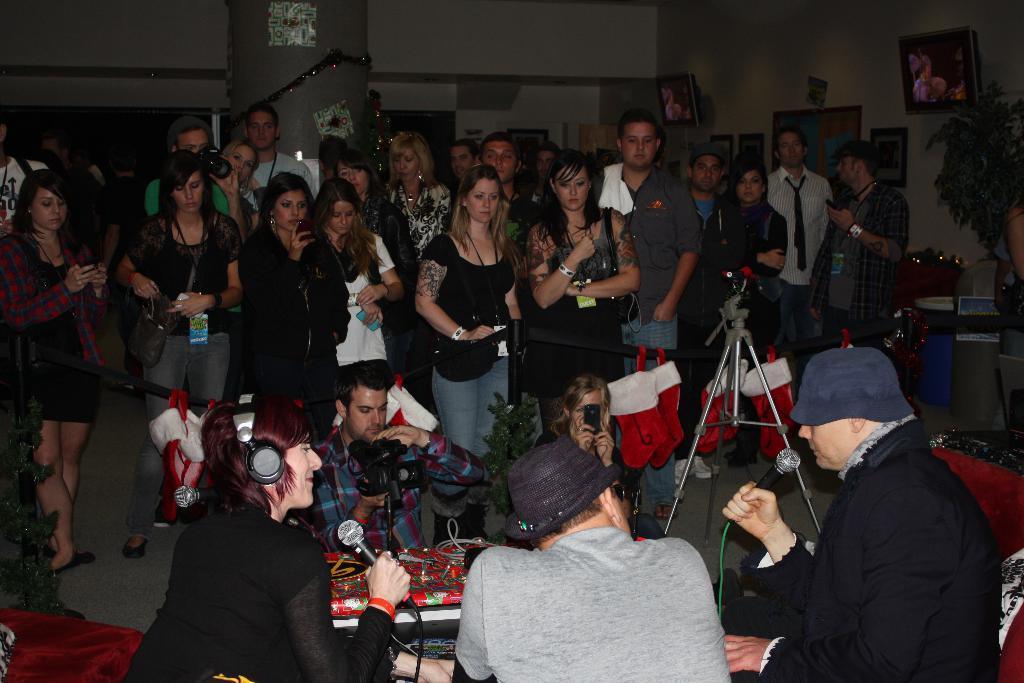Can you describe this image briefly? In this image we can see a group of people, among them, some people are holding the objects, there are some photo frames on the wall, also we can see a stand, plant, cable, pillar and some other objects. 